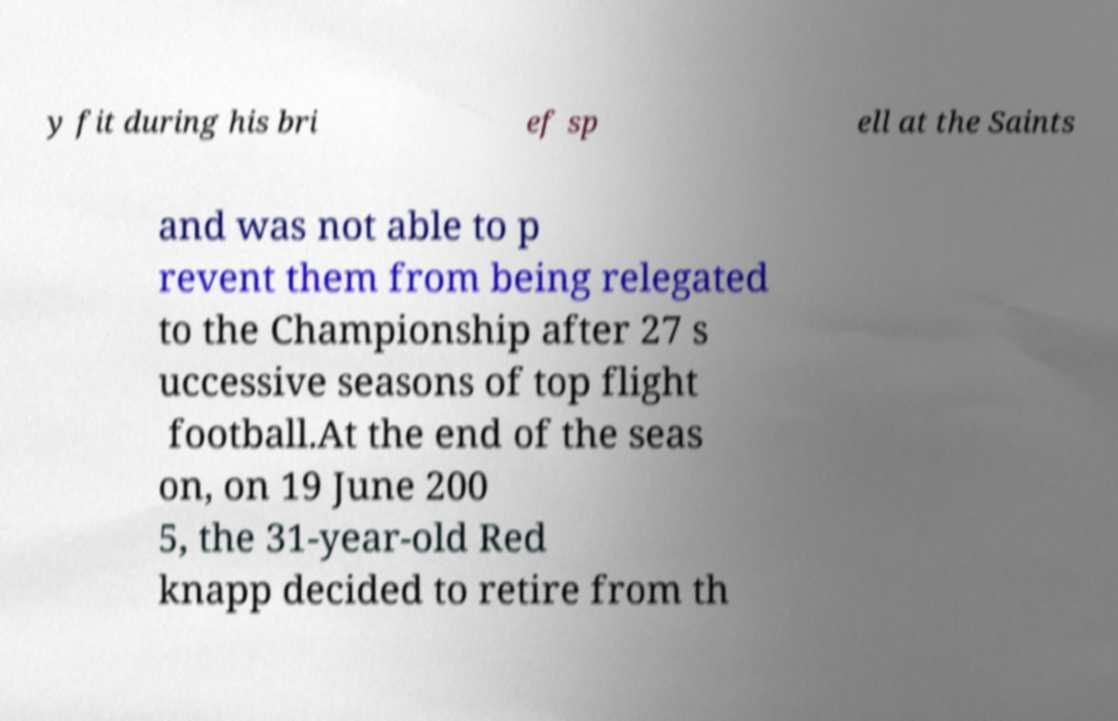Can you accurately transcribe the text from the provided image for me? y fit during his bri ef sp ell at the Saints and was not able to p revent them from being relegated to the Championship after 27 s uccessive seasons of top flight football.At the end of the seas on, on 19 June 200 5, the 31-year-old Red knapp decided to retire from th 